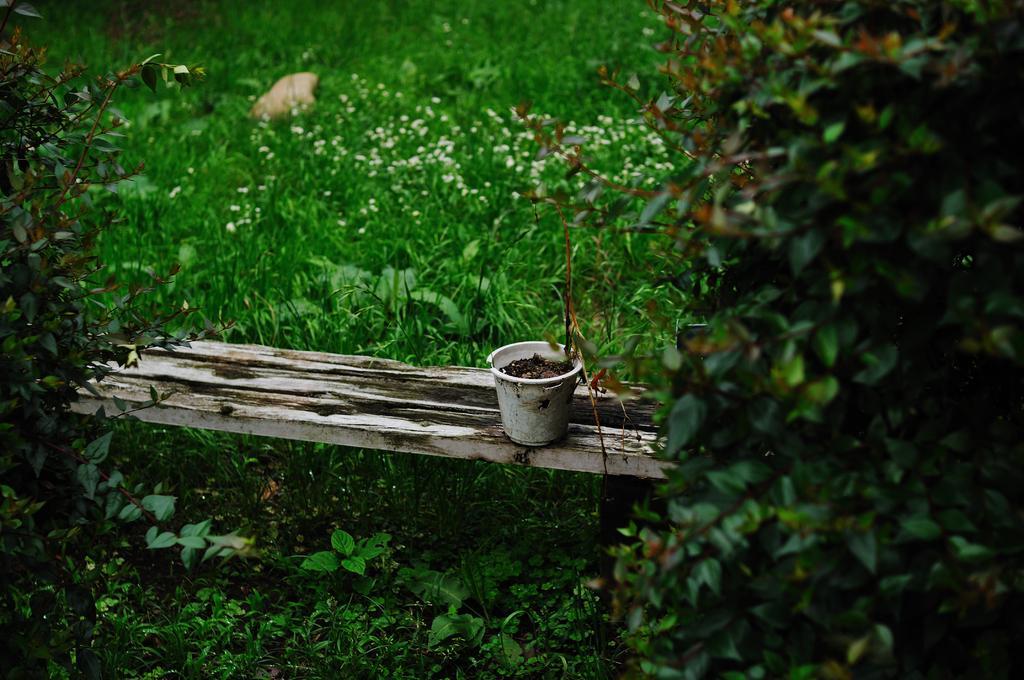How would you summarize this image in a sentence or two? There is a flower pot on the wood. There are also plants over here. 